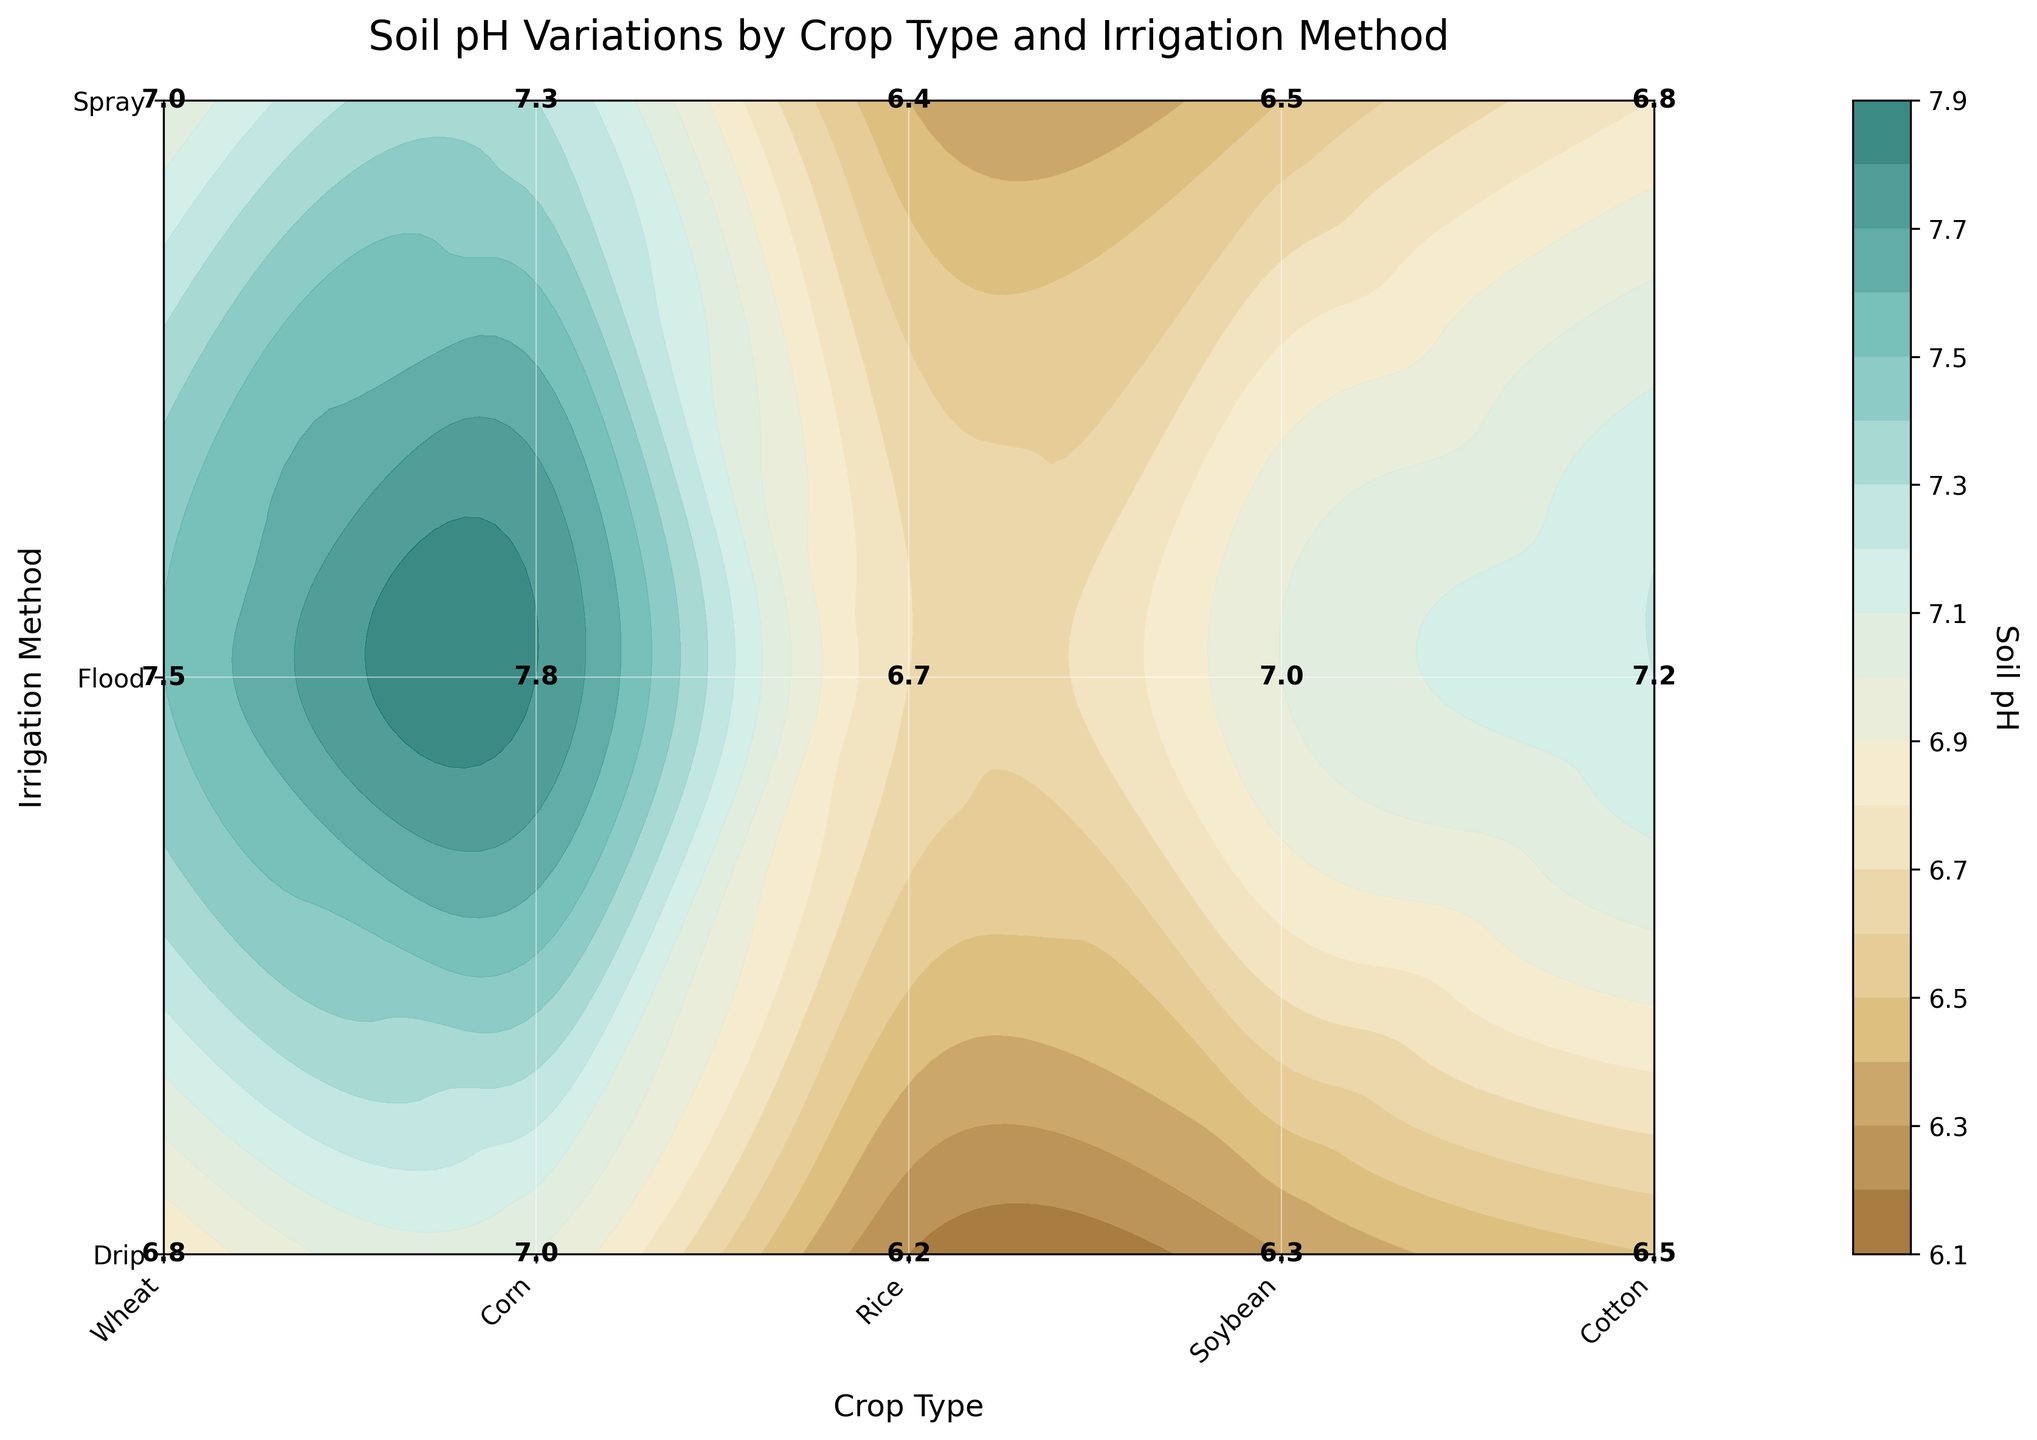What is the title of the contour plot? The title is always displayed prominently at the top of the plot. It provides the primary context for the figure by summarizing what it represents. In this case, the title reads "Soil pH Variations by Crop Type and Irrigation Method."
Answer: Soil pH Variations by Crop Type and Irrigation Method Which axis represents crop type? The crop type is labeled on the horizontal (x) axis, which is indicated by the axis label "Crop Type" at the bottom. The unique crop types listed are Wheat, Corn, Rice, Soybean, and Cotton.
Answer: horizontal How does the soil pH for Wheat compare between the Drip and Flood irrigation methods? Locate the wheat columns and compare the values given in each corresponding cell of the Drip and Flood irrigation rows. Wheat has a pH of 6.5 for Drip and 7.2 for Flood. Flood has a higher pH.
Answer: Flood has a higher pH What is the range of soil pH values displayed in the colorbar? The colorbar indicates the range of data values, which in this plot corresponds to soil pH. The colorbar ranges from the minimum pH value (left end) to the maximum pH value (right end). Observing the ends of the colorbar, it ranges from approximately 6 to 8 pH.
Answer: 6 to 8 Which crop and irrigation method combination has the highest soil pH value? Determine the cell with the maximum pH value by examining all the annotated values in each cell. The highest pH value, 7.8, is found in the Cotton with the Flood irrigation method.
Answer: Cotton with Flood What is the average soil pH for Corn across all irrigation methods? Sum the soil pH values for Corn under Drip, Flood, and Spray irrigation methods: 6.8, 7.5, and 7.0 respectively, then divide by the number of methods (3). The average is calculated as (6.8 + 7.5 + 7.0)/3 = 7.1.
Answer: 7.1 Which irrigation method generally results in lower soil pH values, Drip or Flood? Compare the soil pH values across all crops for both Drip and Flood methods. Drip: 6.5, 6.8, 6.2, 6.3, 7.0. Flood: 7.2, 7.5, 6.7, 7.0, 7.8. On average, Drip values are lower than Flood values.
Answer: Drip How does the soil pH vary from Drip to Spray irrigation methods for Soybean? Locate the Soybean rows for Drip and Spray methods. The soil pH is 6.3 for Drip and 6.5 for Spray. Spray has a slightly higher pH.
Answer: Spray is higher Which crop has the most consistent soil pH across all irrigation methods? Evaluate the variability in pH values across irrigation methods for each crop. The crop with the least variation is Soybean, with values 6.3, 7.0, and 6.5, which are closely clustered around the mean.
Answer: Soybean What is the soil pH difference between Drip and Flood irrigation for Rice? Look at the soil pH values for Rice under Drip and Flood irrigation: 6.2 and 6.7, respectively. The difference is 6.7 - 6.2 = 0.5.
Answer: 0.5 